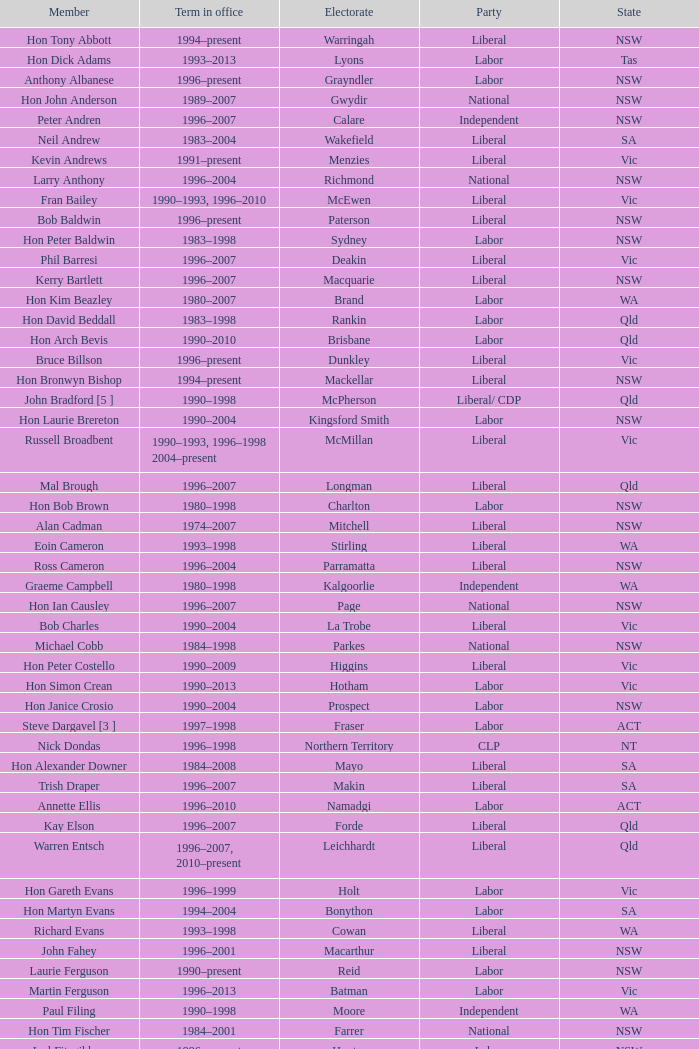In what state was the electorate fowler? NSW. 